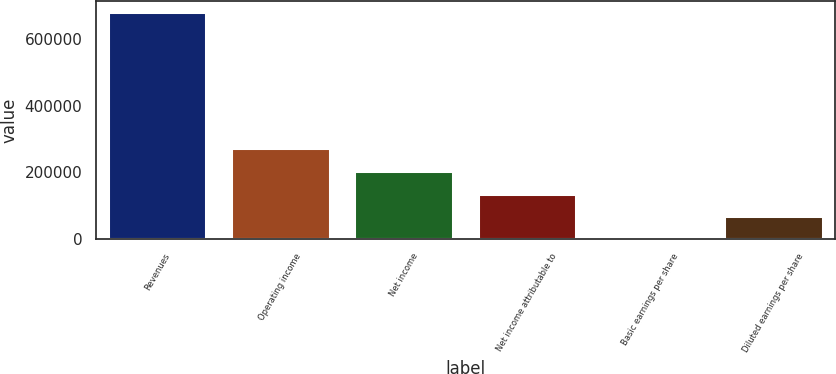<chart> <loc_0><loc_0><loc_500><loc_500><bar_chart><fcel>Revenues<fcel>Operating income<fcel>Net income<fcel>Net income attributable to<fcel>Basic earnings per share<fcel>Diluted earnings per share<nl><fcel>679940<fcel>271976<fcel>203982<fcel>135988<fcel>0.53<fcel>67994.5<nl></chart> 